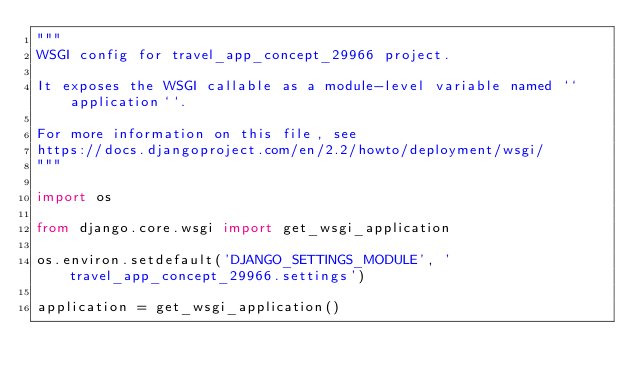Convert code to text. <code><loc_0><loc_0><loc_500><loc_500><_Python_>"""
WSGI config for travel_app_concept_29966 project.

It exposes the WSGI callable as a module-level variable named ``application``.

For more information on this file, see
https://docs.djangoproject.com/en/2.2/howto/deployment/wsgi/
"""

import os

from django.core.wsgi import get_wsgi_application

os.environ.setdefault('DJANGO_SETTINGS_MODULE', 'travel_app_concept_29966.settings')

application = get_wsgi_application()
</code> 